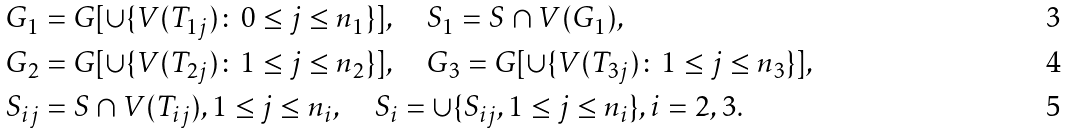<formula> <loc_0><loc_0><loc_500><loc_500>G _ { 1 } & = G [ \cup \{ V ( T _ { 1 j } ) \colon 0 \leq j \leq n _ { 1 } \} ] , \quad S _ { 1 } = S \cap V ( G _ { 1 } ) , \\ G _ { 2 } & = G [ \cup \{ V ( T _ { 2 j } ) \colon 1 \leq j \leq n _ { 2 } \} ] , \quad G _ { 3 } = G [ \cup \{ V ( T _ { 3 j } ) \colon 1 \leq j \leq n _ { 3 } \} ] , \\ S _ { i j } & = S \cap V ( T _ { i j } ) , 1 \leq j \leq n _ { i } , \quad S _ { i } = \cup \{ S _ { i j } , 1 \leq j \leq n _ { i } \} , i = 2 , 3 .</formula> 